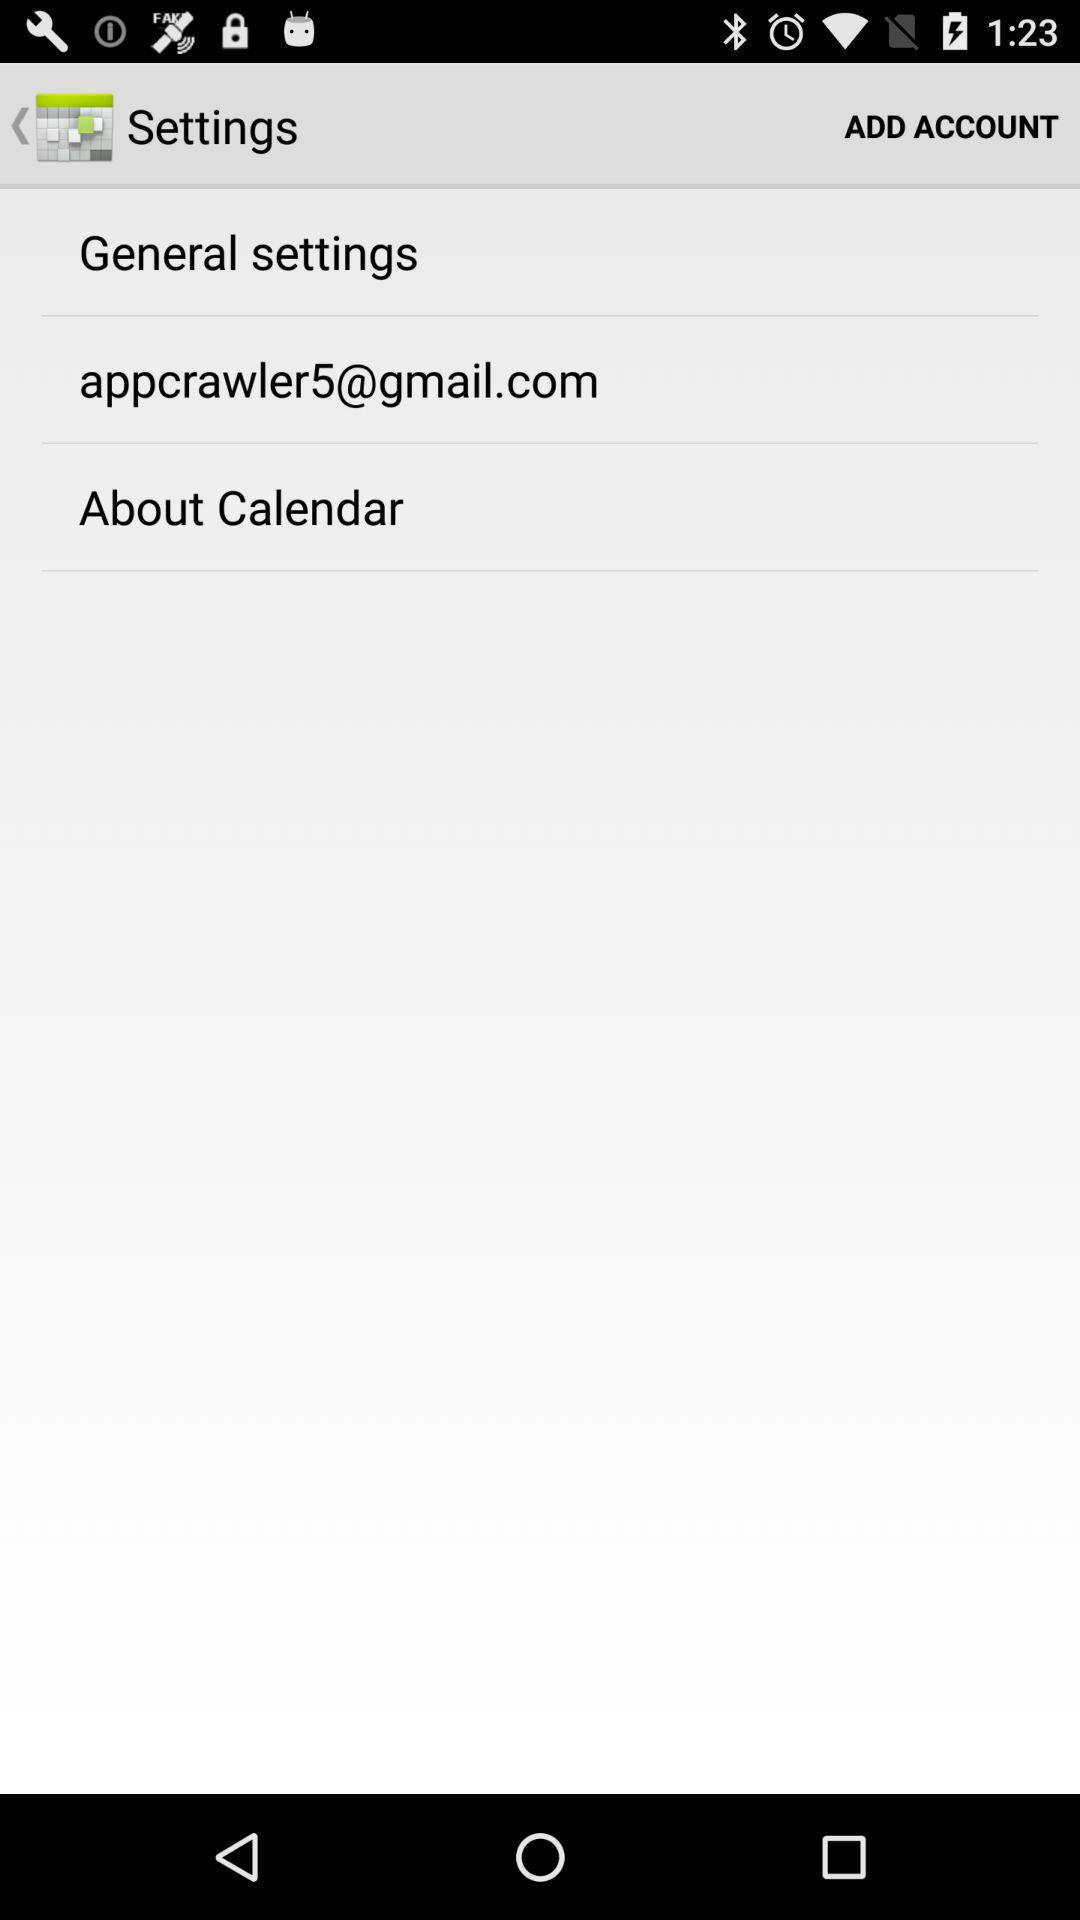What is the email address? The email address is appcrawler5@gmail.com. 